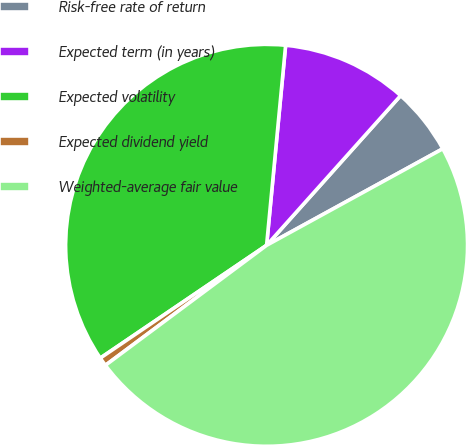Convert chart. <chart><loc_0><loc_0><loc_500><loc_500><pie_chart><fcel>Risk-free rate of return<fcel>Expected term (in years)<fcel>Expected volatility<fcel>Expected dividend yield<fcel>Weighted-average fair value<nl><fcel>5.4%<fcel>10.11%<fcel>35.99%<fcel>0.7%<fcel>47.79%<nl></chart> 